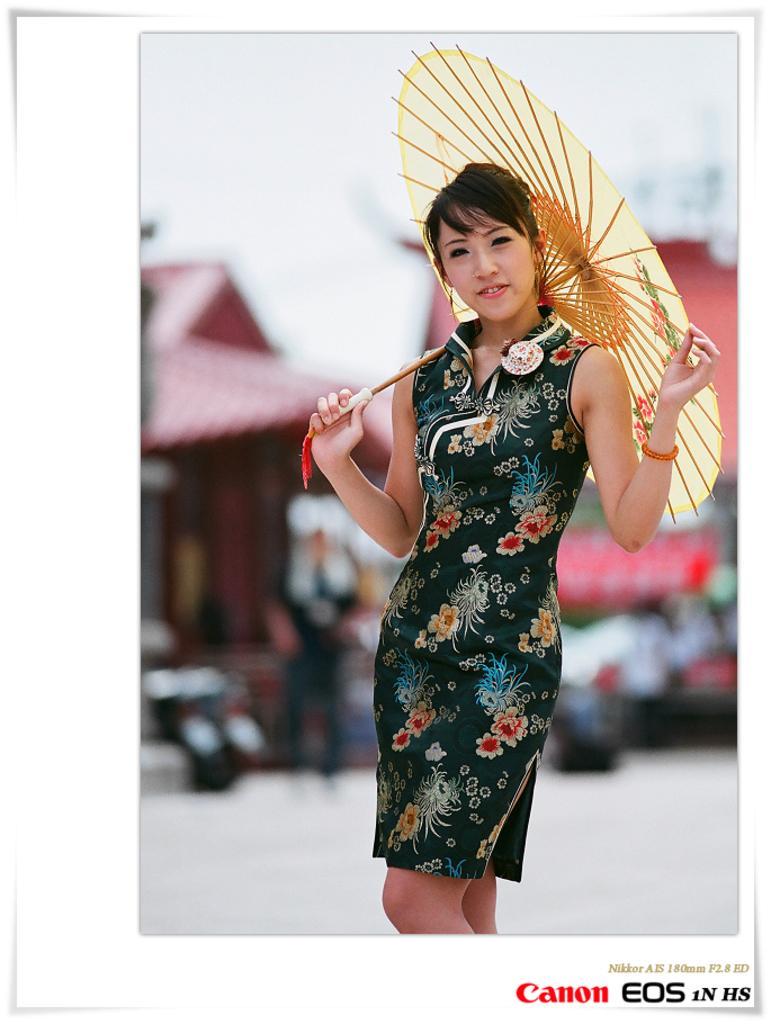Describe this image in one or two sentences. In this image we can see a woman holding an umbrella. There is a blur background. We can see a person and a house. At the bottom of the image we can see something is written on it. 